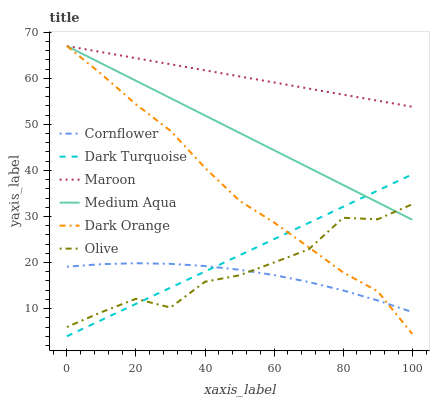Does Cornflower have the minimum area under the curve?
Answer yes or no. Yes. Does Maroon have the maximum area under the curve?
Answer yes or no. Yes. Does Dark Turquoise have the minimum area under the curve?
Answer yes or no. No. Does Dark Turquoise have the maximum area under the curve?
Answer yes or no. No. Is Dark Turquoise the smoothest?
Answer yes or no. Yes. Is Olive the roughest?
Answer yes or no. Yes. Is Cornflower the smoothest?
Answer yes or no. No. Is Cornflower the roughest?
Answer yes or no. No. Does Dark Turquoise have the lowest value?
Answer yes or no. Yes. Does Cornflower have the lowest value?
Answer yes or no. No. Does Medium Aqua have the highest value?
Answer yes or no. Yes. Does Dark Turquoise have the highest value?
Answer yes or no. No. Is Cornflower less than Maroon?
Answer yes or no. Yes. Is Maroon greater than Dark Turquoise?
Answer yes or no. Yes. Does Cornflower intersect Dark Turquoise?
Answer yes or no. Yes. Is Cornflower less than Dark Turquoise?
Answer yes or no. No. Is Cornflower greater than Dark Turquoise?
Answer yes or no. No. Does Cornflower intersect Maroon?
Answer yes or no. No. 